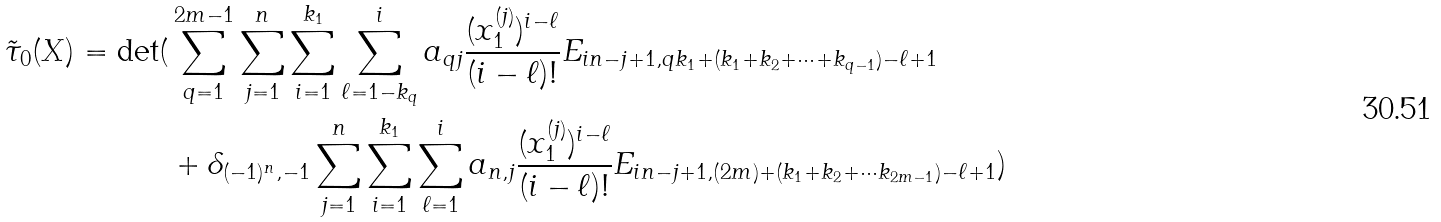<formula> <loc_0><loc_0><loc_500><loc_500>\tilde { \tau } _ { 0 } ( X ) = \det ( & \sum _ { q = 1 } ^ { 2 m - 1 } \sum _ { j = 1 } ^ { n } \sum _ { i = 1 } ^ { k _ { 1 } } \sum _ { \ell = 1 - k _ { q } } ^ { i } a _ { q j } \frac { ( x _ { 1 } ^ { ( j ) } ) ^ { i - \ell } } { ( i - \ell ) ! } E _ { i n - j + 1 , q k _ { 1 } + ( k _ { 1 } + k _ { 2 } + \cdots + k _ { q - 1 } ) - \ell + 1 } \\ \ & + \delta _ { ( - 1 ) ^ { n } , - 1 } \sum _ { j = 1 } ^ { n } \sum _ { i = 1 } ^ { k _ { 1 } } \sum _ { \ell = 1 } ^ { i } a _ { n , j } \frac { ( x _ { 1 } ^ { ( j ) } ) ^ { i - \ell } } { ( i - \ell ) ! } E _ { i n - j + 1 , ( 2 m ) + ( k _ { 1 } + k _ { 2 } + \cdots k _ { 2 m - 1 } ) - \ell + 1 } ) \\</formula> 